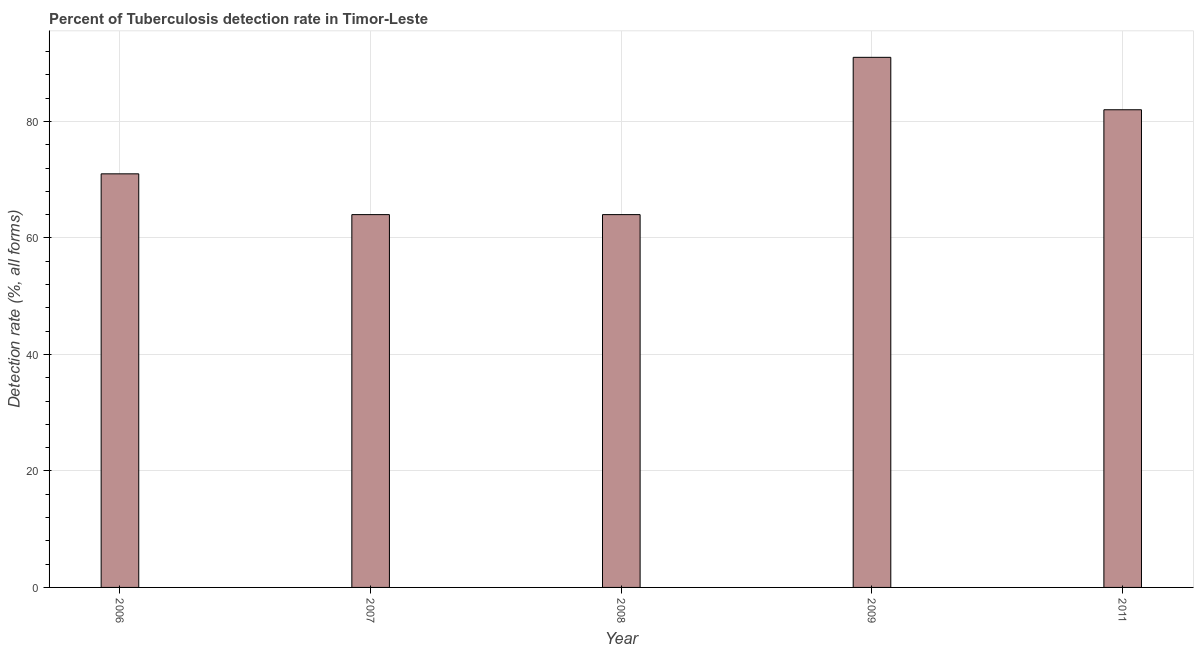What is the title of the graph?
Offer a very short reply. Percent of Tuberculosis detection rate in Timor-Leste. What is the label or title of the Y-axis?
Make the answer very short. Detection rate (%, all forms). Across all years, what is the maximum detection rate of tuberculosis?
Give a very brief answer. 91. Across all years, what is the minimum detection rate of tuberculosis?
Give a very brief answer. 64. In which year was the detection rate of tuberculosis maximum?
Your response must be concise. 2009. In which year was the detection rate of tuberculosis minimum?
Your answer should be very brief. 2007. What is the sum of the detection rate of tuberculosis?
Offer a very short reply. 372. What is the difference between the detection rate of tuberculosis in 2007 and 2008?
Offer a very short reply. 0. What is the ratio of the detection rate of tuberculosis in 2007 to that in 2011?
Keep it short and to the point. 0.78. Is the detection rate of tuberculosis in 2006 less than that in 2007?
Offer a terse response. No. Is the difference between the detection rate of tuberculosis in 2006 and 2009 greater than the difference between any two years?
Keep it short and to the point. No. In how many years, is the detection rate of tuberculosis greater than the average detection rate of tuberculosis taken over all years?
Provide a succinct answer. 2. Are all the bars in the graph horizontal?
Your answer should be very brief. No. What is the Detection rate (%, all forms) in 2009?
Keep it short and to the point. 91. What is the Detection rate (%, all forms) in 2011?
Provide a succinct answer. 82. What is the difference between the Detection rate (%, all forms) in 2006 and 2007?
Provide a short and direct response. 7. What is the difference between the Detection rate (%, all forms) in 2006 and 2009?
Provide a succinct answer. -20. What is the difference between the Detection rate (%, all forms) in 2006 and 2011?
Your answer should be very brief. -11. What is the difference between the Detection rate (%, all forms) in 2008 and 2009?
Your answer should be compact. -27. What is the difference between the Detection rate (%, all forms) in 2009 and 2011?
Offer a very short reply. 9. What is the ratio of the Detection rate (%, all forms) in 2006 to that in 2007?
Keep it short and to the point. 1.11. What is the ratio of the Detection rate (%, all forms) in 2006 to that in 2008?
Ensure brevity in your answer.  1.11. What is the ratio of the Detection rate (%, all forms) in 2006 to that in 2009?
Your response must be concise. 0.78. What is the ratio of the Detection rate (%, all forms) in 2006 to that in 2011?
Make the answer very short. 0.87. What is the ratio of the Detection rate (%, all forms) in 2007 to that in 2008?
Your answer should be compact. 1. What is the ratio of the Detection rate (%, all forms) in 2007 to that in 2009?
Your answer should be compact. 0.7. What is the ratio of the Detection rate (%, all forms) in 2007 to that in 2011?
Ensure brevity in your answer.  0.78. What is the ratio of the Detection rate (%, all forms) in 2008 to that in 2009?
Keep it short and to the point. 0.7. What is the ratio of the Detection rate (%, all forms) in 2008 to that in 2011?
Give a very brief answer. 0.78. What is the ratio of the Detection rate (%, all forms) in 2009 to that in 2011?
Your response must be concise. 1.11. 